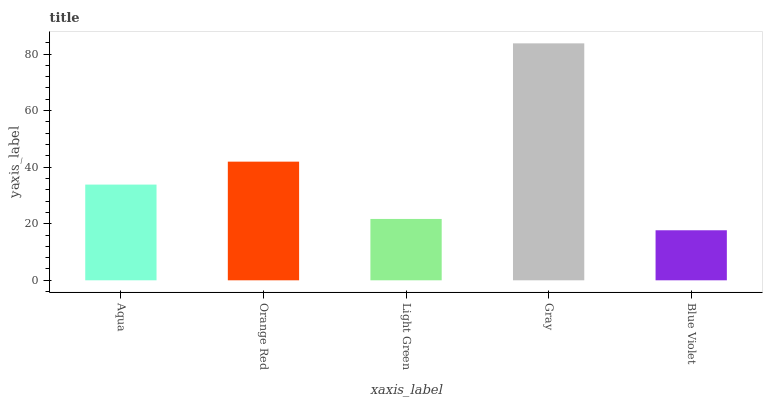Is Orange Red the minimum?
Answer yes or no. No. Is Orange Red the maximum?
Answer yes or no. No. Is Orange Red greater than Aqua?
Answer yes or no. Yes. Is Aqua less than Orange Red?
Answer yes or no. Yes. Is Aqua greater than Orange Red?
Answer yes or no. No. Is Orange Red less than Aqua?
Answer yes or no. No. Is Aqua the high median?
Answer yes or no. Yes. Is Aqua the low median?
Answer yes or no. Yes. Is Gray the high median?
Answer yes or no. No. Is Blue Violet the low median?
Answer yes or no. No. 